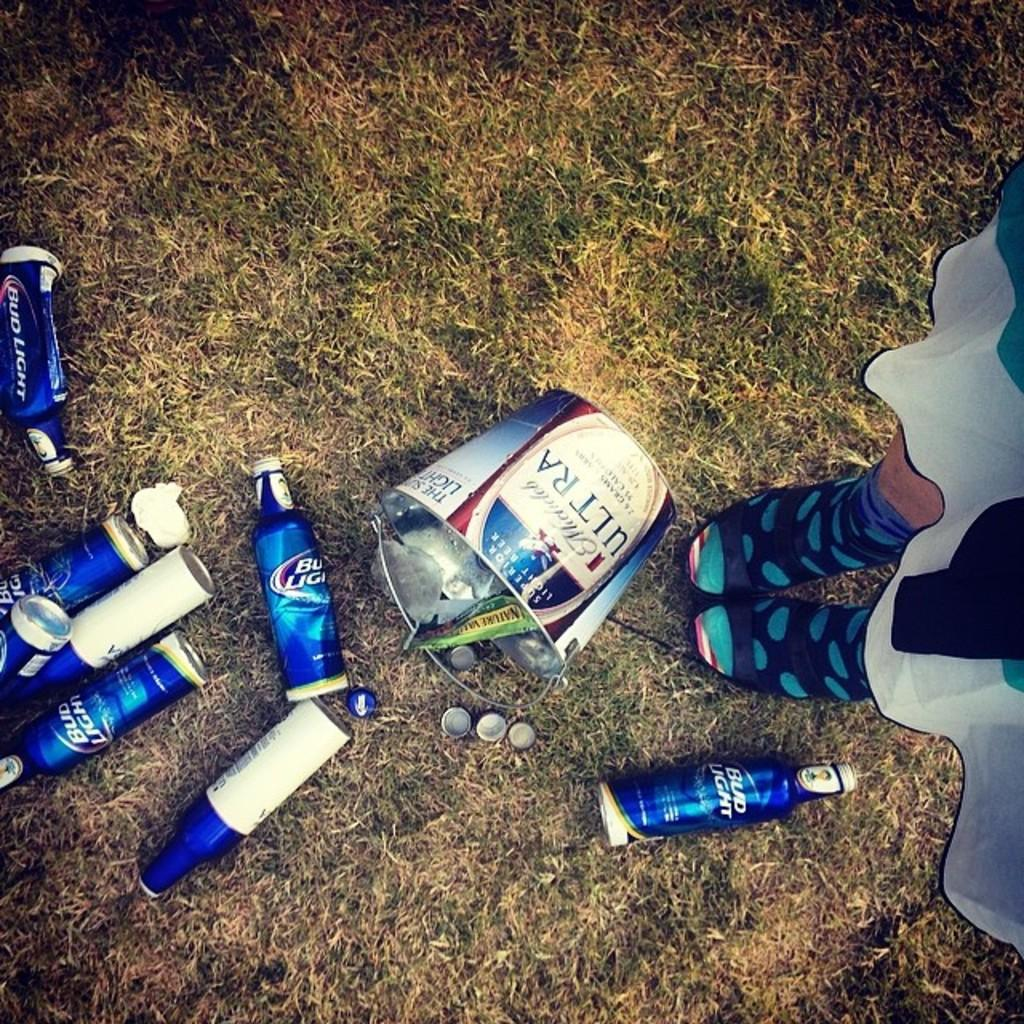<image>
Present a compact description of the photo's key features. A bucket of empty Bud Light was thrown on a grassy ground. 